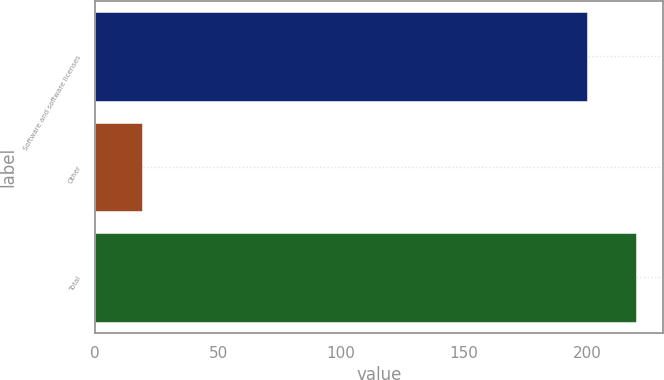Convert chart to OTSL. <chart><loc_0><loc_0><loc_500><loc_500><bar_chart><fcel>Software and software licenses<fcel>Other<fcel>Total<nl><fcel>200<fcel>19<fcel>220<nl></chart> 